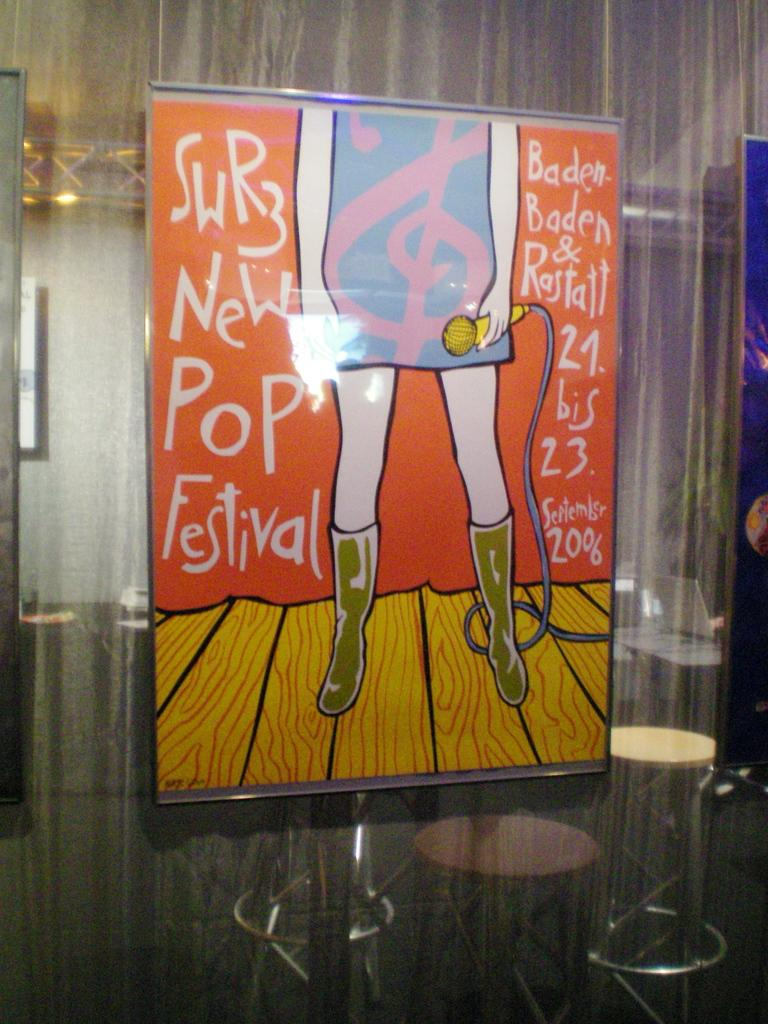What object in the image contains an image? There is a photo frame in the image, and it contains an animated image. What type of image is present in the photo frame? The image in the photo frame is an animated image. What is the person in the image doing? The person is standing in the image and holding a mic. What type of juice is being served in the image? There is no juice present in the image. What type of educational material can be seen in the image? There is no educational material present in the image. What type of tooth is visible in the image? There is no tooth visible in the image. 